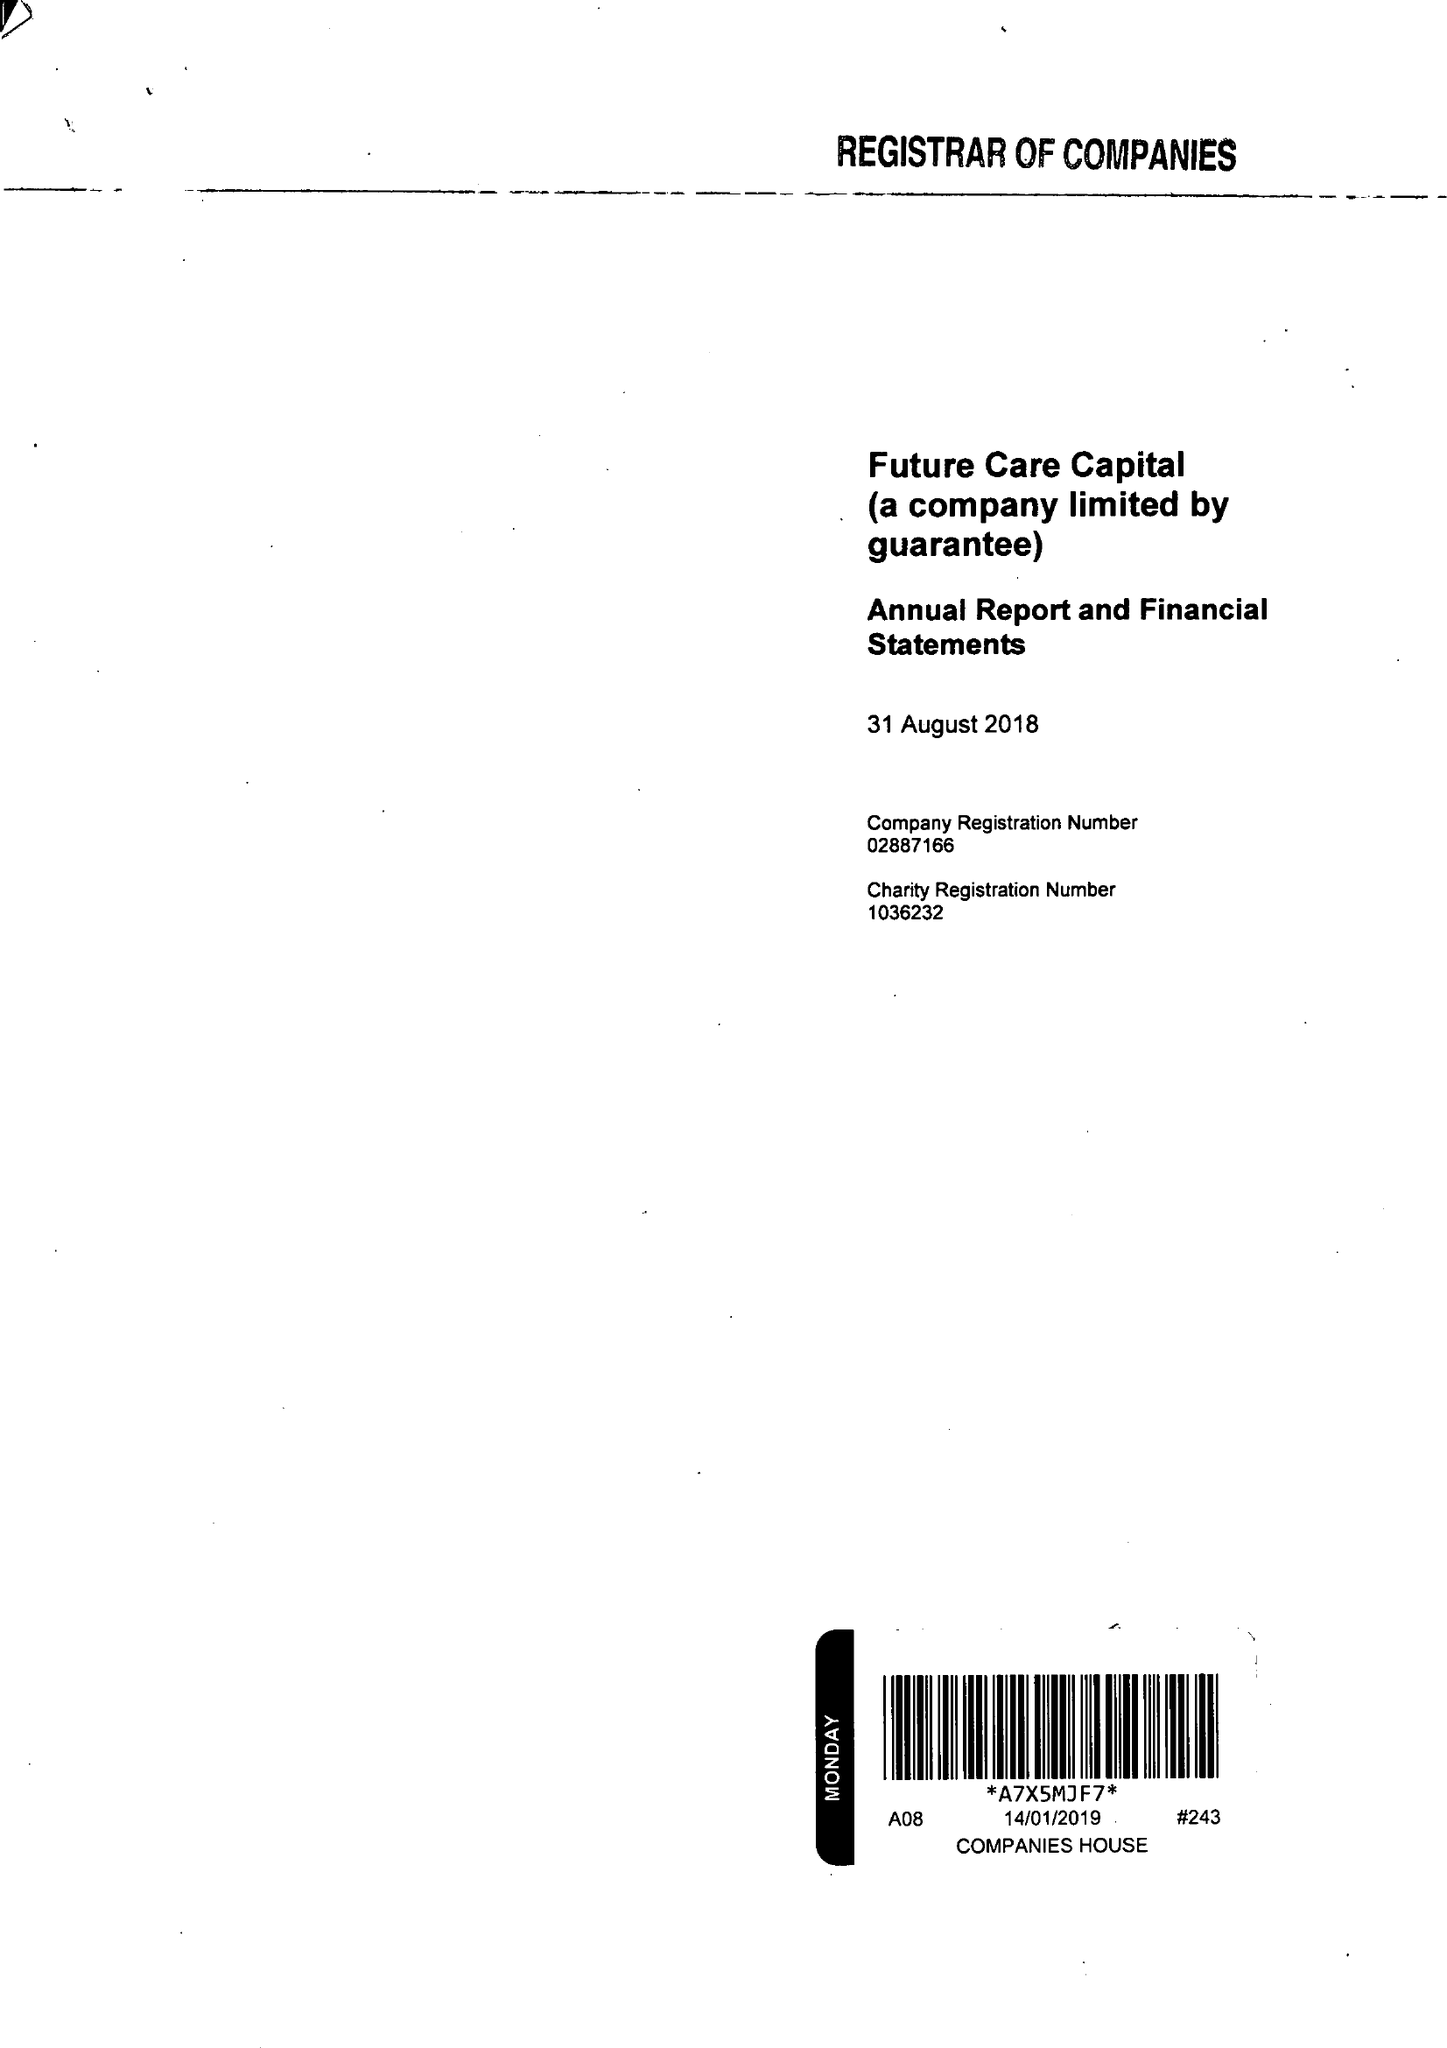What is the value for the address__street_line?
Answer the question using a single word or phrase. 38-44 GILLINGHAM STREET 